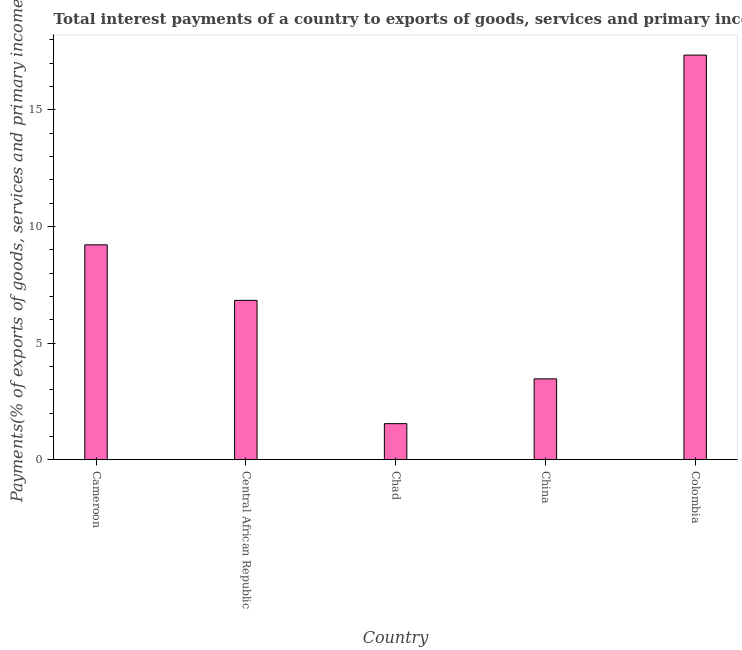Does the graph contain any zero values?
Your response must be concise. No. What is the title of the graph?
Offer a terse response. Total interest payments of a country to exports of goods, services and primary income in 1986. What is the label or title of the X-axis?
Make the answer very short. Country. What is the label or title of the Y-axis?
Your answer should be very brief. Payments(% of exports of goods, services and primary income). What is the total interest payments on external debt in Cameroon?
Offer a terse response. 9.21. Across all countries, what is the maximum total interest payments on external debt?
Your response must be concise. 17.35. Across all countries, what is the minimum total interest payments on external debt?
Your response must be concise. 1.55. In which country was the total interest payments on external debt minimum?
Make the answer very short. Chad. What is the sum of the total interest payments on external debt?
Offer a terse response. 38.41. What is the difference between the total interest payments on external debt in Cameroon and Central African Republic?
Offer a very short reply. 2.38. What is the average total interest payments on external debt per country?
Ensure brevity in your answer.  7.68. What is the median total interest payments on external debt?
Keep it short and to the point. 6.83. In how many countries, is the total interest payments on external debt greater than 8 %?
Your answer should be compact. 2. What is the ratio of the total interest payments on external debt in Chad to that in Colombia?
Your response must be concise. 0.09. What is the difference between the highest and the second highest total interest payments on external debt?
Give a very brief answer. 8.14. Is the sum of the total interest payments on external debt in Cameroon and Colombia greater than the maximum total interest payments on external debt across all countries?
Your answer should be very brief. Yes. What is the difference between the highest and the lowest total interest payments on external debt?
Your answer should be compact. 15.81. How many bars are there?
Offer a very short reply. 5. Are all the bars in the graph horizontal?
Offer a very short reply. No. How many countries are there in the graph?
Ensure brevity in your answer.  5. What is the Payments(% of exports of goods, services and primary income) of Cameroon?
Make the answer very short. 9.21. What is the Payments(% of exports of goods, services and primary income) in Central African Republic?
Ensure brevity in your answer.  6.83. What is the Payments(% of exports of goods, services and primary income) in Chad?
Offer a terse response. 1.55. What is the Payments(% of exports of goods, services and primary income) of China?
Give a very brief answer. 3.47. What is the Payments(% of exports of goods, services and primary income) of Colombia?
Provide a short and direct response. 17.35. What is the difference between the Payments(% of exports of goods, services and primary income) in Cameroon and Central African Republic?
Ensure brevity in your answer.  2.38. What is the difference between the Payments(% of exports of goods, services and primary income) in Cameroon and Chad?
Your answer should be compact. 7.67. What is the difference between the Payments(% of exports of goods, services and primary income) in Cameroon and China?
Your answer should be very brief. 5.75. What is the difference between the Payments(% of exports of goods, services and primary income) in Cameroon and Colombia?
Keep it short and to the point. -8.14. What is the difference between the Payments(% of exports of goods, services and primary income) in Central African Republic and Chad?
Provide a succinct answer. 5.29. What is the difference between the Payments(% of exports of goods, services and primary income) in Central African Republic and China?
Provide a succinct answer. 3.37. What is the difference between the Payments(% of exports of goods, services and primary income) in Central African Republic and Colombia?
Provide a succinct answer. -10.52. What is the difference between the Payments(% of exports of goods, services and primary income) in Chad and China?
Your answer should be very brief. -1.92. What is the difference between the Payments(% of exports of goods, services and primary income) in Chad and Colombia?
Offer a terse response. -15.81. What is the difference between the Payments(% of exports of goods, services and primary income) in China and Colombia?
Offer a terse response. -13.88. What is the ratio of the Payments(% of exports of goods, services and primary income) in Cameroon to that in Central African Republic?
Your answer should be compact. 1.35. What is the ratio of the Payments(% of exports of goods, services and primary income) in Cameroon to that in Chad?
Offer a terse response. 5.96. What is the ratio of the Payments(% of exports of goods, services and primary income) in Cameroon to that in China?
Keep it short and to the point. 2.66. What is the ratio of the Payments(% of exports of goods, services and primary income) in Cameroon to that in Colombia?
Make the answer very short. 0.53. What is the ratio of the Payments(% of exports of goods, services and primary income) in Central African Republic to that in Chad?
Keep it short and to the point. 4.42. What is the ratio of the Payments(% of exports of goods, services and primary income) in Central African Republic to that in China?
Ensure brevity in your answer.  1.97. What is the ratio of the Payments(% of exports of goods, services and primary income) in Central African Republic to that in Colombia?
Make the answer very short. 0.39. What is the ratio of the Payments(% of exports of goods, services and primary income) in Chad to that in China?
Your answer should be compact. 0.45. What is the ratio of the Payments(% of exports of goods, services and primary income) in Chad to that in Colombia?
Provide a succinct answer. 0.09. What is the ratio of the Payments(% of exports of goods, services and primary income) in China to that in Colombia?
Provide a short and direct response. 0.2. 